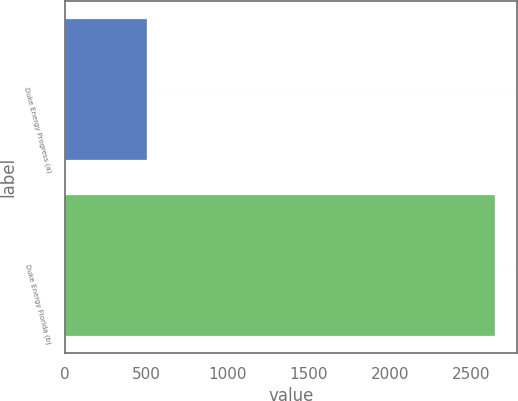Convert chart. <chart><loc_0><loc_0><loc_500><loc_500><bar_chart><fcel>Duke Energy Progress (a)<fcel>Duke Energy Florida (b)<nl><fcel>508<fcel>2649<nl></chart> 